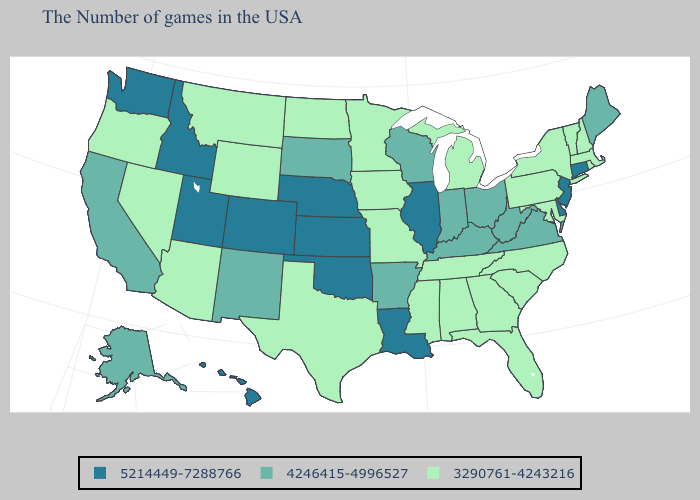Is the legend a continuous bar?
Keep it brief. No. What is the value of Kansas?
Be succinct. 5214449-7288766. Name the states that have a value in the range 4246415-4996527?
Give a very brief answer. Maine, Virginia, West Virginia, Ohio, Kentucky, Indiana, Wisconsin, Arkansas, South Dakota, New Mexico, California, Alaska. What is the value of Wisconsin?
Be succinct. 4246415-4996527. Does Connecticut have the lowest value in the Northeast?
Keep it brief. No. Name the states that have a value in the range 3290761-4243216?
Give a very brief answer. Massachusetts, Rhode Island, New Hampshire, Vermont, New York, Maryland, Pennsylvania, North Carolina, South Carolina, Florida, Georgia, Michigan, Alabama, Tennessee, Mississippi, Missouri, Minnesota, Iowa, Texas, North Dakota, Wyoming, Montana, Arizona, Nevada, Oregon. What is the lowest value in states that border Kansas?
Quick response, please. 3290761-4243216. Does the first symbol in the legend represent the smallest category?
Write a very short answer. No. Does Oklahoma have a higher value than Georgia?
Write a very short answer. Yes. What is the value of Wisconsin?
Give a very brief answer. 4246415-4996527. What is the value of Delaware?
Short answer required. 5214449-7288766. Does Oklahoma have the highest value in the South?
Keep it brief. Yes. Does Nevada have the lowest value in the USA?
Quick response, please. Yes. Name the states that have a value in the range 3290761-4243216?
Quick response, please. Massachusetts, Rhode Island, New Hampshire, Vermont, New York, Maryland, Pennsylvania, North Carolina, South Carolina, Florida, Georgia, Michigan, Alabama, Tennessee, Mississippi, Missouri, Minnesota, Iowa, Texas, North Dakota, Wyoming, Montana, Arizona, Nevada, Oregon. Which states have the lowest value in the USA?
Short answer required. Massachusetts, Rhode Island, New Hampshire, Vermont, New York, Maryland, Pennsylvania, North Carolina, South Carolina, Florida, Georgia, Michigan, Alabama, Tennessee, Mississippi, Missouri, Minnesota, Iowa, Texas, North Dakota, Wyoming, Montana, Arizona, Nevada, Oregon. 